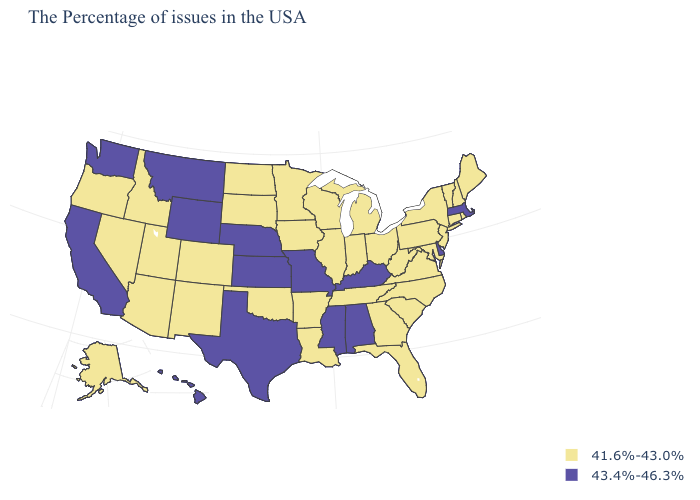Name the states that have a value in the range 43.4%-46.3%?
Give a very brief answer. Massachusetts, Delaware, Kentucky, Alabama, Mississippi, Missouri, Kansas, Nebraska, Texas, Wyoming, Montana, California, Washington, Hawaii. What is the value of Florida?
Quick response, please. 41.6%-43.0%. Among the states that border North Carolina , which have the lowest value?
Quick response, please. Virginia, South Carolina, Georgia, Tennessee. Name the states that have a value in the range 43.4%-46.3%?
Concise answer only. Massachusetts, Delaware, Kentucky, Alabama, Mississippi, Missouri, Kansas, Nebraska, Texas, Wyoming, Montana, California, Washington, Hawaii. How many symbols are there in the legend?
Concise answer only. 2. What is the highest value in the West ?
Keep it brief. 43.4%-46.3%. Does Maryland have a lower value than West Virginia?
Quick response, please. No. Among the states that border Missouri , which have the highest value?
Give a very brief answer. Kentucky, Kansas, Nebraska. What is the value of Louisiana?
Write a very short answer. 41.6%-43.0%. What is the highest value in the USA?
Keep it brief. 43.4%-46.3%. Does Georgia have the lowest value in the South?
Be succinct. Yes. Does Kansas have the highest value in the MidWest?
Quick response, please. Yes. Is the legend a continuous bar?
Give a very brief answer. No. What is the highest value in the USA?
Short answer required. 43.4%-46.3%. 